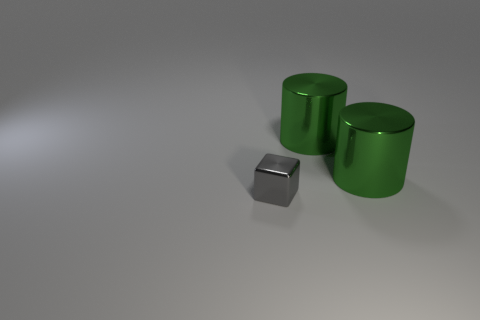What number of metal things are gray blocks or cylinders?
Provide a succinct answer. 3. What number of other things are there of the same material as the gray block
Ensure brevity in your answer.  2. How many things are either large blue objects or things that are right of the gray block?
Offer a terse response. 2. Are there any cylinders of the same size as the gray metal thing?
Make the answer very short. No. What is the material of the gray object?
Your answer should be compact. Metal. There is a block; what number of metallic cylinders are behind it?
Your answer should be very brief. 2. How many other blocks are the same color as the metal cube?
Offer a very short reply. 0. Is the number of tiny cyan metallic balls greater than the number of gray cubes?
Keep it short and to the point. No. Are there fewer big things than gray objects?
Ensure brevity in your answer.  No. Is the number of green shiny things that are in front of the gray shiny object less than the number of gray metal objects?
Make the answer very short. Yes. 